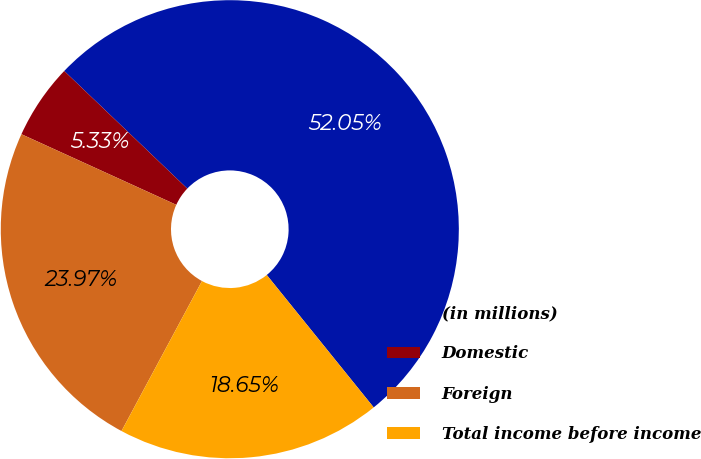Convert chart. <chart><loc_0><loc_0><loc_500><loc_500><pie_chart><fcel>(in millions)<fcel>Domestic<fcel>Foreign<fcel>Total income before income<nl><fcel>52.05%<fcel>5.33%<fcel>23.97%<fcel>18.65%<nl></chart> 